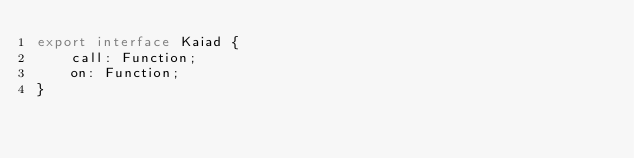<code> <loc_0><loc_0><loc_500><loc_500><_TypeScript_>export interface Kaiad {
    call: Function;
    on: Function;
}
</code> 